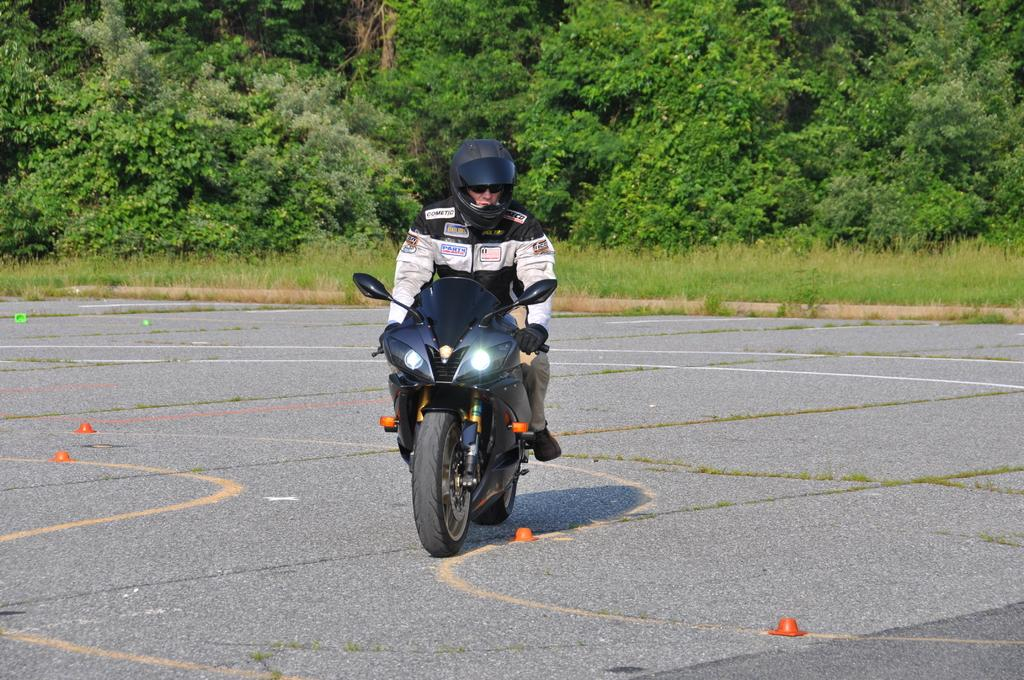Where was the image taken? The image was taken outside. What is the person in the image doing? The person is riding a bike in the image. How is the bike positioned in the image? The bike is on the ground. What type of vegetation can be seen in the background of the image? There is green grass, plants, and trees in the background of the image. Can you tell me how many straws are being used by the person riding the bike in the image? There are no straws present in the image; the person is riding a bike, not using straws. Who is the partner of the person riding the bike in the image? There is no partner visible in the image; only the person riding the bike can be seen. 